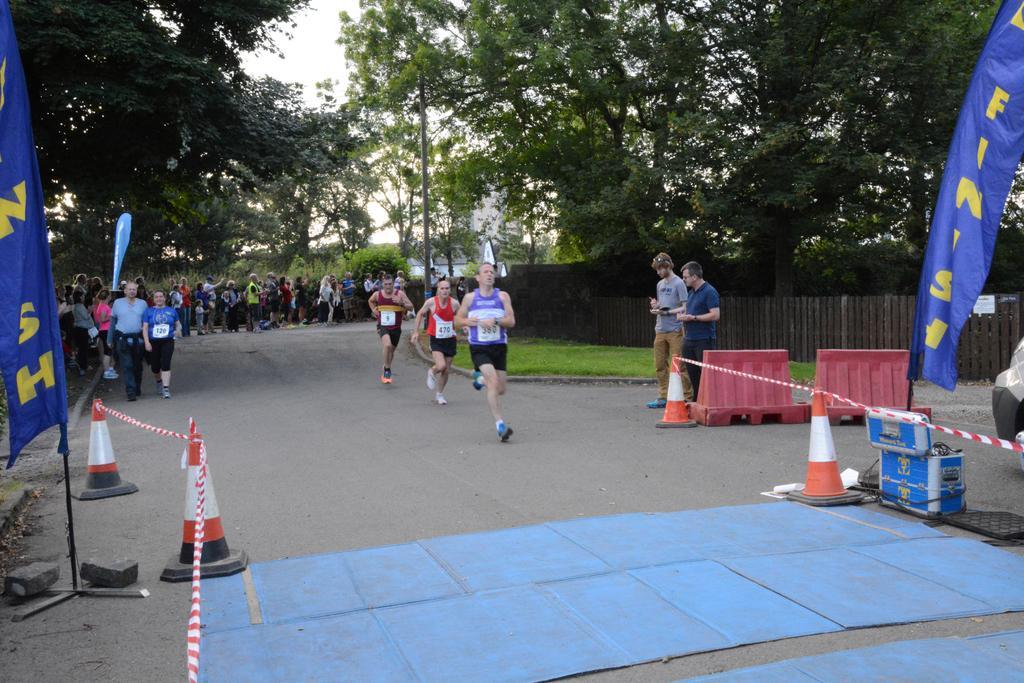In one or two sentences, can you explain what this image depicts? In this picture I can observe three members running on the road. I can observe traffic cones on either sides of the picture. There are blue color banners on either sides of the picture. I can observe some people standing on the road. In the background there are trees and sky. 